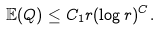<formula> <loc_0><loc_0><loc_500><loc_500>\mathbb { E } ( Q ) \leq C _ { 1 } r ( \log r ) ^ { C } .</formula> 